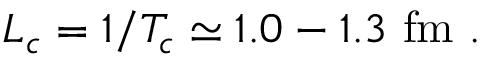Convert formula to latex. <formula><loc_0><loc_0><loc_500><loc_500>L _ { c } = 1 / T _ { c } \simeq 1 . 0 - 1 . 3 \ f m \ .</formula> 